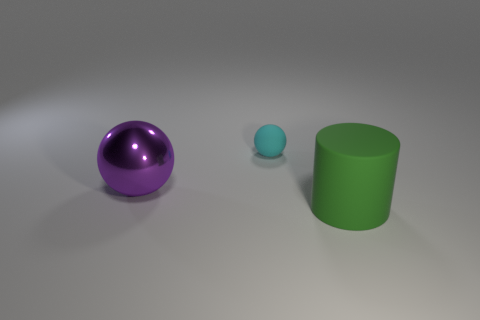Please describe the lighting condition in the image. The image portrays diffuse lighting, providing a soft illumination with shadows indicating an overhead light source, possibly simulating ambient daylight. 